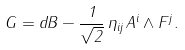Convert formula to latex. <formula><loc_0><loc_0><loc_500><loc_500>G = d B - \frac { 1 } { \sqrt { 2 } } \, \eta _ { i j } \, A ^ { i } \wedge F ^ { j } .</formula> 